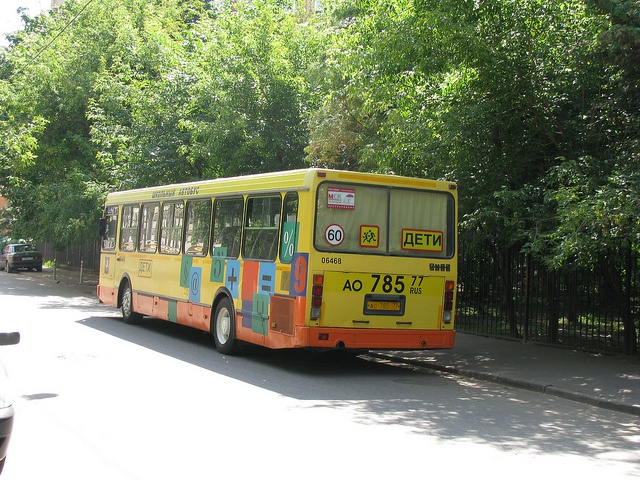Describe the objects in this image and their specific colors. I can see bus in white, gray, olive, and black tones and car in white, black, gray, and darkgray tones in this image. 